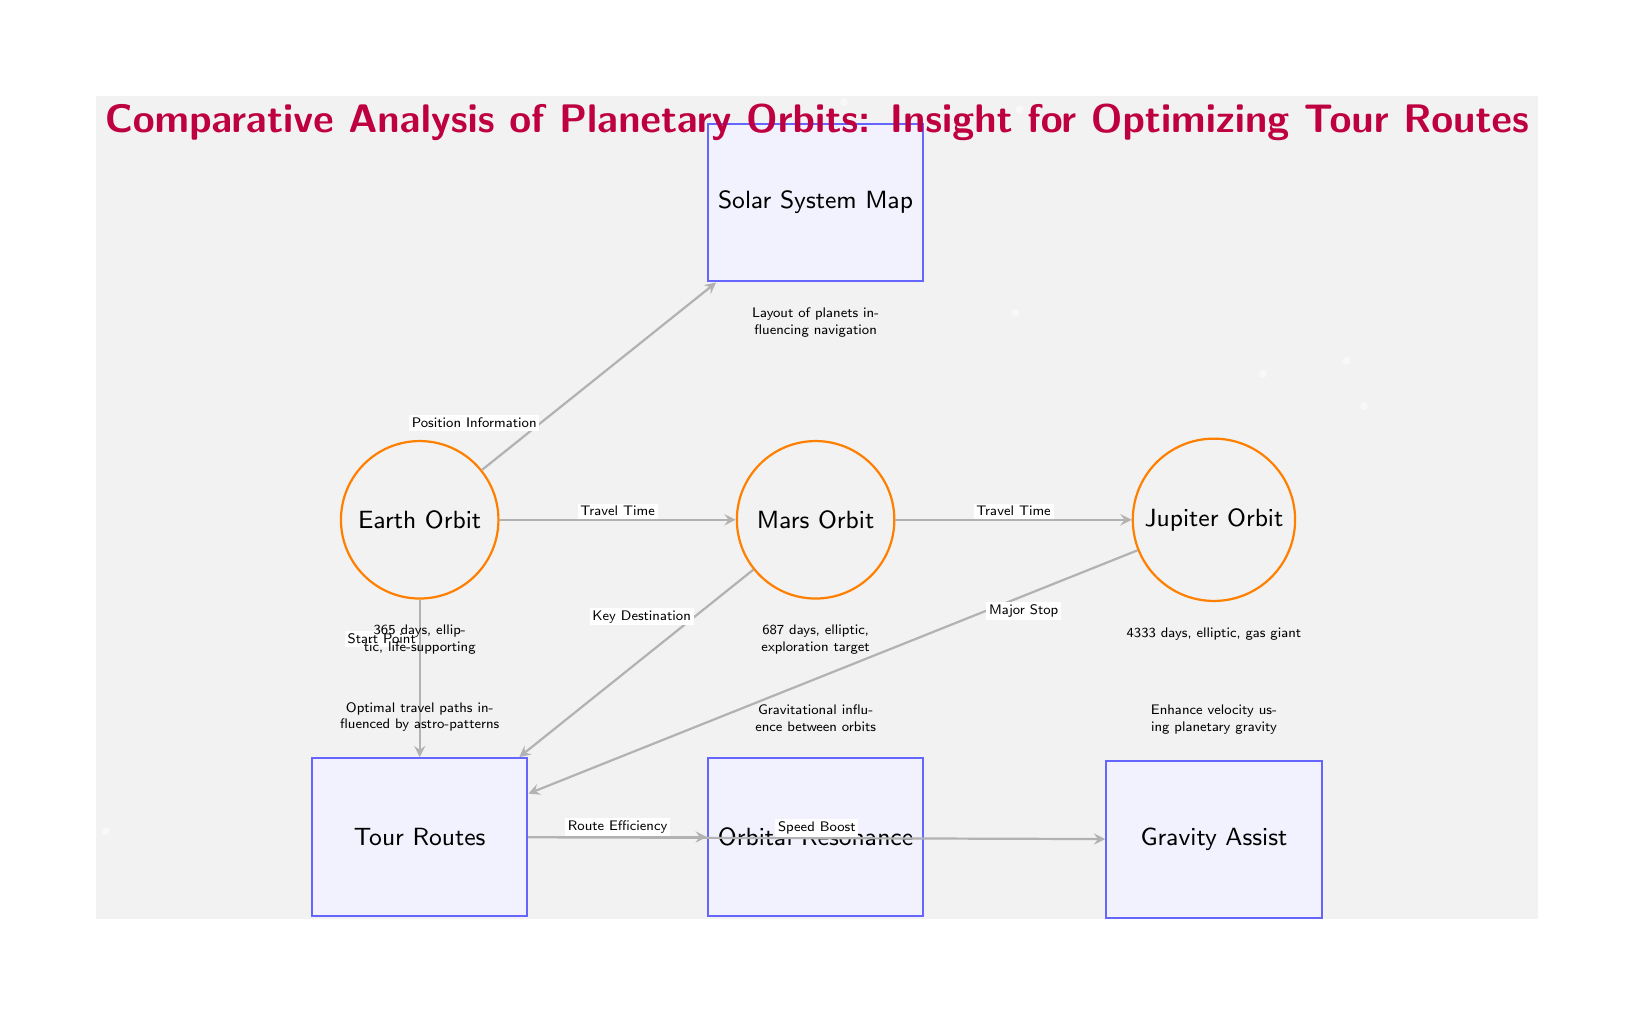What are the orbits depicted in the diagram? The diagram shows three orbits: Earth Orbit, Mars Orbit, and Jupiter Orbit. These can be identified by looking at the labeled nodes on the top row of the diagram.
Answer: Earth Orbit, Mars Orbit, Jupiter Orbit What is the travel time from Earth to Mars? The travel time between Earth and Mars is indicated by the label on the arrow connecting these two orbits. The label states "Travel Time," but no specific duration is mentioned in the diagram. Thus, we refer to the general understanding of travel times.
Answer: Not specified What does the 'Gravity Assist' concept refer to? The 'Gravity Assist' concept is explained in the diagram as enhancing velocity using planetary gravity. This is found as a label connected to the 'Routes' concept, showing how gravity can influence the efficiency of travel.
Answer: Enhance velocity using planetary gravity How many concepts are connected to the 'Routes' node? To determine the number of connections, look at the edges originating from the 'Routes' node. There are three outgoing edges connecting 'Routes' to 'Resonance,' 'Gravity,' and the three orbits (Earth, Mars, and Jupiter indirectly).
Answer: Four Why are optimal travel paths influenced by astro-patterns? Optimal travel paths are influenced by astro-patterns, which can be found in the description near the 'Routes' node. It indicates that these paths are determined by interactions and layouts within the solar system, which include various factors.
Answer: Gravitational influence and layout of planets What is the duration of the Mars orbit? The Mars orbit is described under the Mars node, indicating that it takes 687 days. This value is directly stated in the description located just below the Mars Orbit node.
Answer: 687 days What type of information is represented by the 'Solar System Map' node? The 'Solar System Map' node represents the layout of planets influencing navigation. This can be deduced from the description below the 'Map' node.
Answer: Layout of planets influencing navigation What is the relationship between 'Routes' and 'Orbital Resonance'? The relationship is indicated by an arrow connecting the 'Routes' concept to 'Orbital Resonance.' The label on the arrow indicates 'Route Efficiency,' showing how the routes are affected by resonance.
Answer: Route Efficiency How does the travel time from Mars to Jupiter relate to Earth to Mars? The travel times are both labeled as 'Travel Time.' The relationship is sequential, as traveling from Earth to Mars occurs before traveling from Mars to Jupiter. Each journey's time can impact overall travel planning.
Answer: Sequential relation 